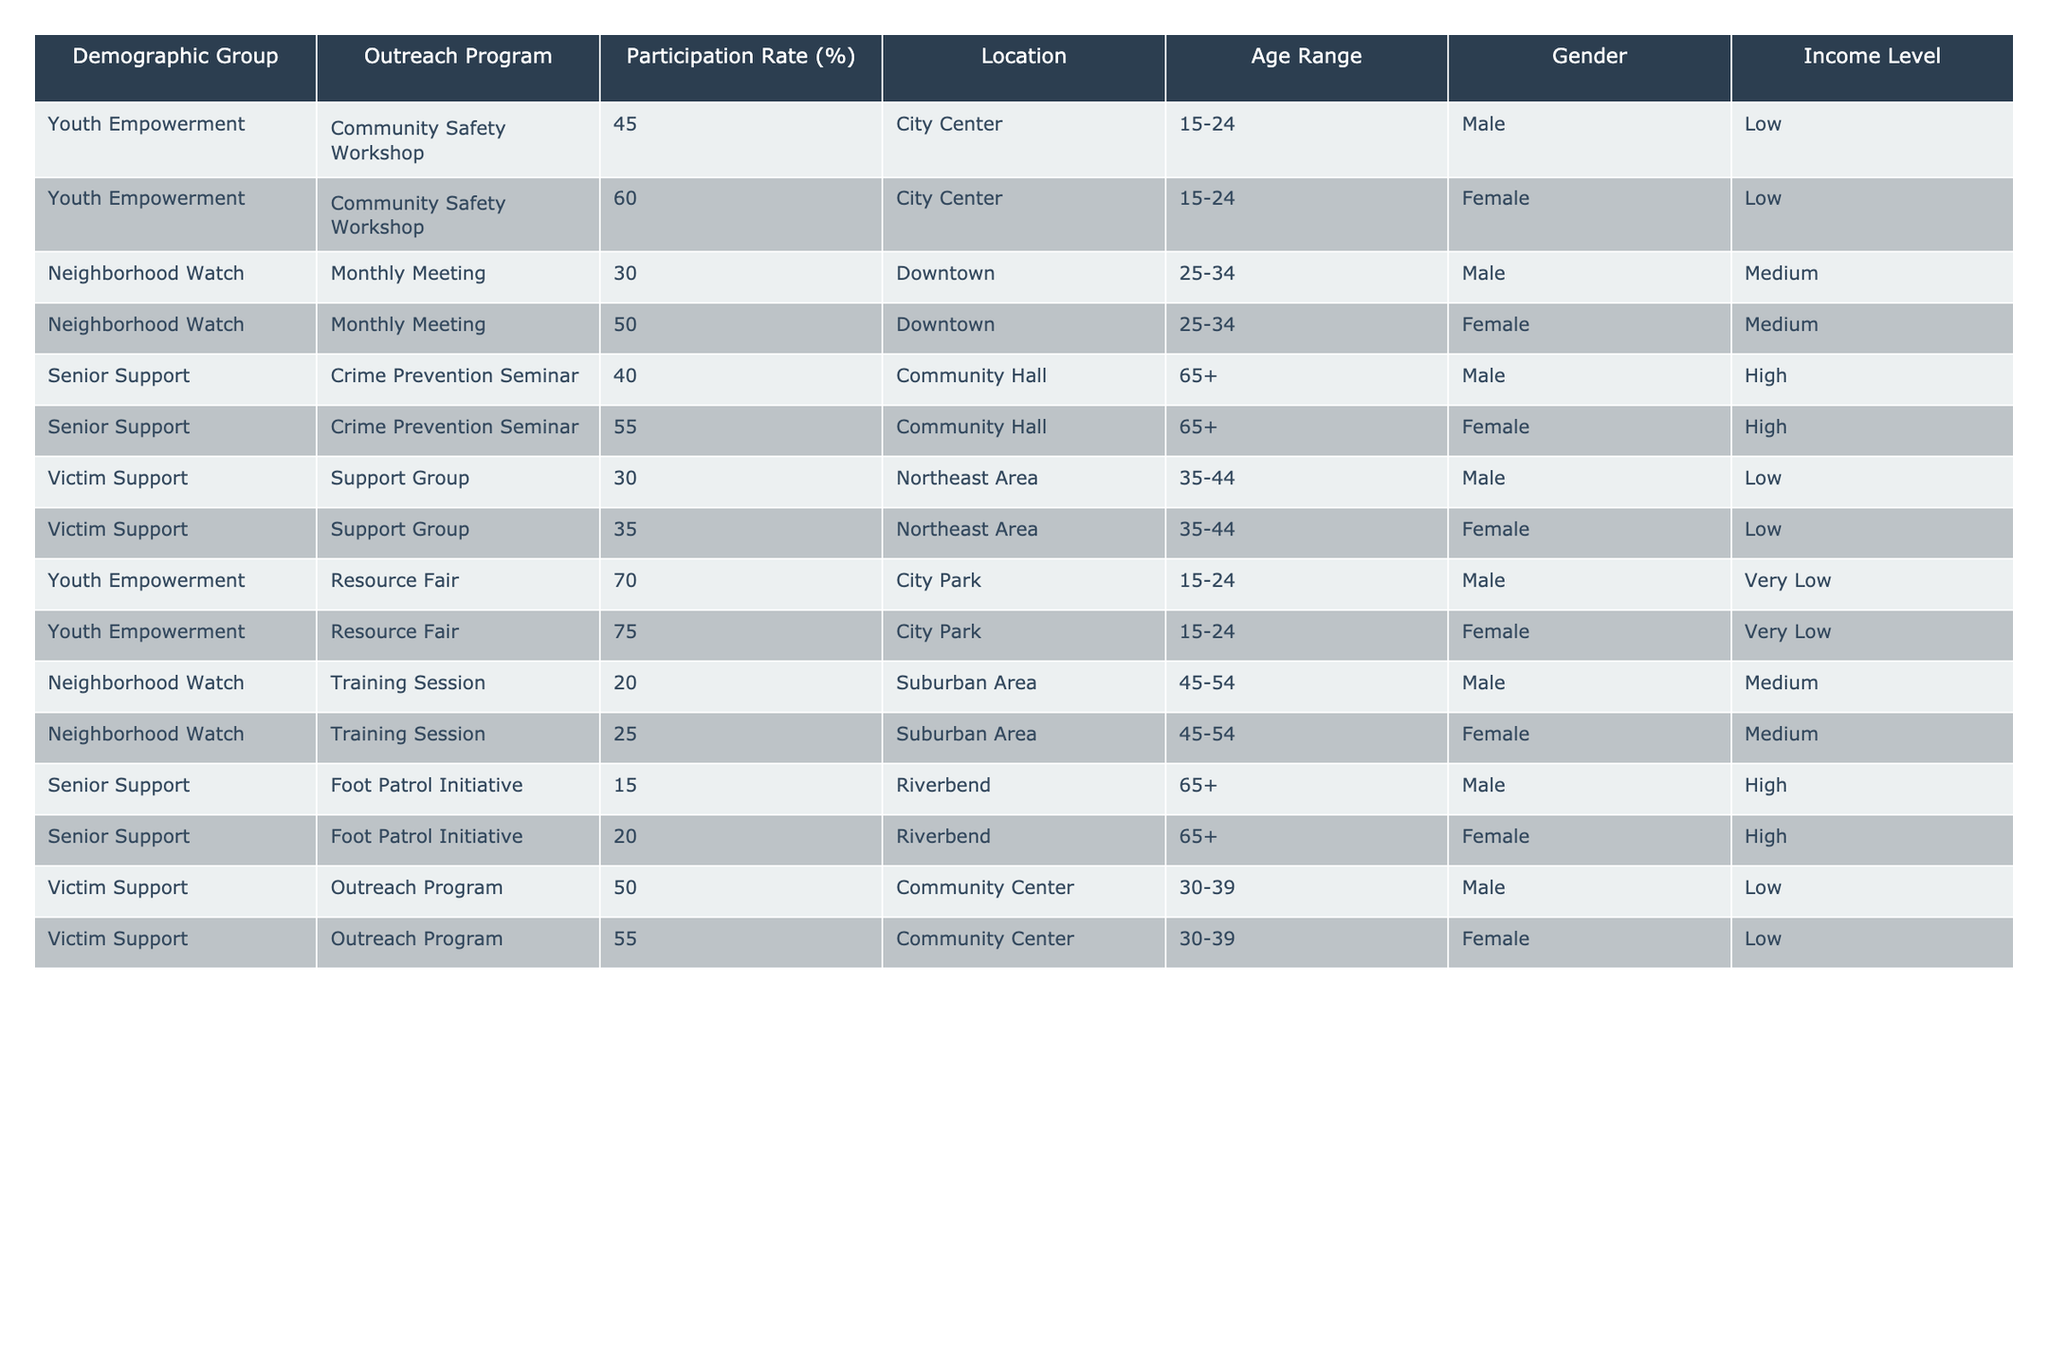What is the participation rate of the Youth Empowerment program for males at the Community Safety Workshop? The Youth Empowerment program has a participation rate of 45% for males at the Community Safety Workshop, as shown in the table.
Answer: 45% Which demographic group has the highest participation rate in the Resource Fair? The table indicates that the Youth Empowerment program has the highest participation rate at 70% for the Resource Fair.
Answer: 70% Is the participation rate of females in the Senior Support program's Crime Prevention Seminar higher than that of males? The participation rate for females is 55% and for males is 40% in the Crime Prevention Seminar, hence females have a higher rate.
Answer: Yes What is the average participation rate for the Neighborhood Watch program across both genders? The participation rates are 30% for males and 50% for females in the Monthly Meeting, and 20% for males and 25% for females in the Training Session. The average is calculated as (30+50+20+25)/4 = 26.25%.
Answer: 26.25% In which location did the highest participation rate occur for the Youth Empowerment program? The Resource Fair at City Park shows the highest participation rate at 70%, which is higher than the Community Safety Workshop's rates at City Center.
Answer: City Park What is the difference in participation rates between males and females in the Senior Support Foot Patrol Initiative? The participation rate for males is 15% and for females is 20%, resulting in a difference of 20% - 15% = 5%.
Answer: 5% Are participation rates in the Victim Support programs generally lower than those in the Youth Empowerment programs? Yes, the participation rates for Victim Support programs range from 30% to 55%, whereas Youth Empowerment has rates up to 75%.
Answer: Yes Which age range has the lowest participation rate in the Neighborhood Watch program? The data shows that the Training Session has a participation rate of 20% for males and 25% for females, making it the lowest for that demographic group.
Answer: 20% How does the participation rate of males compare to females in the Victim Support programs? Males have participation rates of 30% and 50%, while females have 35% and 55%. Overall, females have higher rates in both instances.
Answer: Females have higher rates What is the total participation rate for males across all outreach programs listed? By summing males' rates: 45 + 30 + 40 + 30 + 70 + 20 + 15 = 250%. There are 7 data points for males, thus the total participation rate is 250/7 = 35.71%.
Answer: 35.71% 